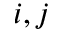<formula> <loc_0><loc_0><loc_500><loc_500>i , j</formula> 